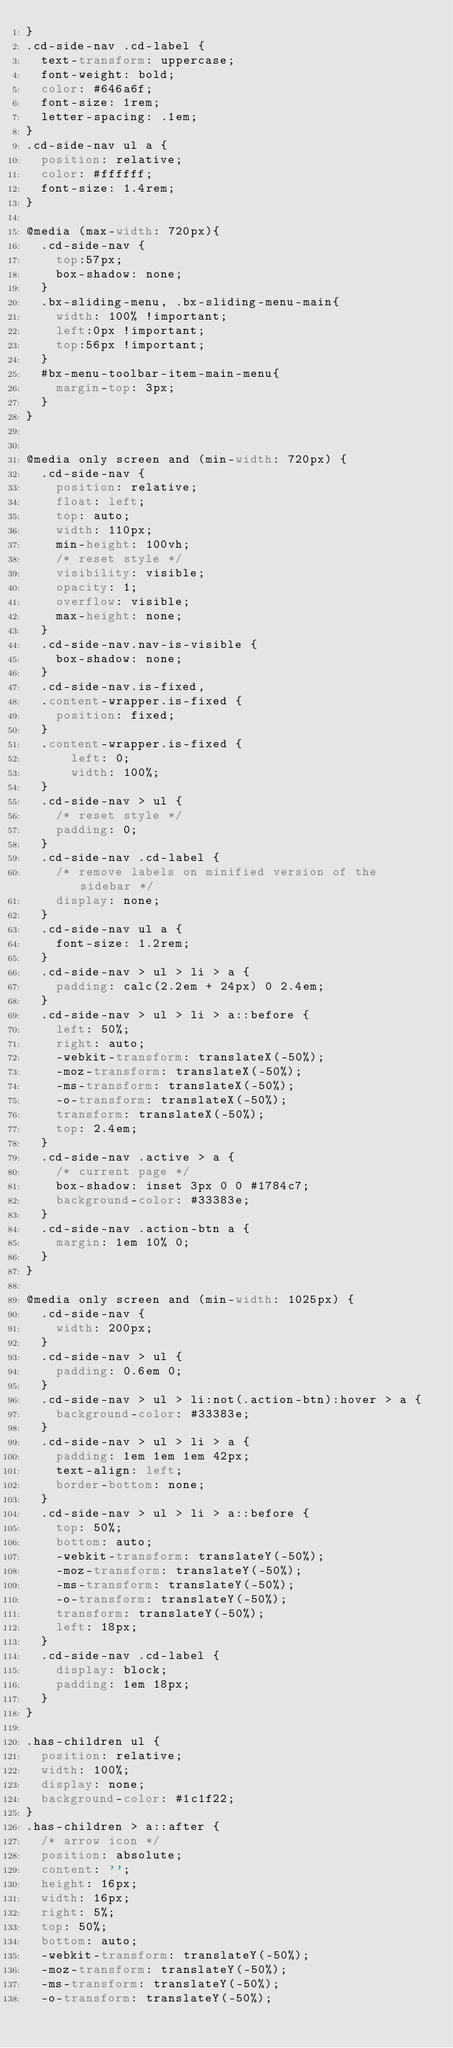Convert code to text. <code><loc_0><loc_0><loc_500><loc_500><_CSS_>}
.cd-side-nav .cd-label {
  text-transform: uppercase;
  font-weight: bold;
  color: #646a6f;
  font-size: 1rem;
  letter-spacing: .1em;
}
.cd-side-nav ul a {
  position: relative;
  color: #ffffff;
  font-size: 1.4rem;
}

@media (max-width: 720px){
	.cd-side-nav {
		top:57px;
		box-shadow: none;
	}
	.bx-sliding-menu, .bx-sliding-menu-main{
		width: 100% !important;
		left:0px !important;
		top:56px !important;
	}
	#bx-menu-toolbar-item-main-menu{
		margin-top: 3px;
	}
}

	
@media only screen and (min-width: 720px) {
  .cd-side-nav {
    position: relative;
    float: left;
    top: auto;
    width: 110px;
    min-height: 100vh;
    /* reset style */
    visibility: visible;
    opacity: 1;
    overflow: visible;
    max-height: none;
  }
  .cd-side-nav.nav-is-visible {
    box-shadow: none;
  }
  .cd-side-nav.is-fixed,
  .content-wrapper.is-fixed {
    position: fixed;
  }
  .content-wrapper.is-fixed {
      left: 0;
      width: 100%;
  }
  .cd-side-nav > ul {
    /* reset style */
    padding: 0;
  }
  .cd-side-nav .cd-label {
    /* remove labels on minified version of the sidebar */
    display: none;
  }
  .cd-side-nav ul a {
    font-size: 1.2rem;
  }
  .cd-side-nav > ul > li > a {
    padding: calc(2.2em + 24px) 0 2.4em;
  }
  .cd-side-nav > ul > li > a::before {
    left: 50%;
    right: auto;
    -webkit-transform: translateX(-50%);
    -moz-transform: translateX(-50%);
    -ms-transform: translateX(-50%);
    -o-transform: translateX(-50%);
    transform: translateX(-50%);
    top: 2.4em;
  }
  .cd-side-nav .active > a {
    /* current page */
    box-shadow: inset 3px 0 0 #1784c7;
    background-color: #33383e;
  }
  .cd-side-nav .action-btn a {
    margin: 1em 10% 0;
  }
}

@media only screen and (min-width: 1025px) {
  .cd-side-nav {
    width: 200px;
  }
  .cd-side-nav > ul {
    padding: 0.6em 0;
  }
  .cd-side-nav > ul > li:not(.action-btn):hover > a {
    background-color: #33383e;
  }
  .cd-side-nav > ul > li > a {
    padding: 1em 1em 1em 42px;
    text-align: left;
    border-bottom: none;
  }
  .cd-side-nav > ul > li > a::before {
    top: 50%;
    bottom: auto;
    -webkit-transform: translateY(-50%);
    -moz-transform: translateY(-50%);
    -ms-transform: translateY(-50%);
    -o-transform: translateY(-50%);
    transform: translateY(-50%);
    left: 18px;
  }
  .cd-side-nav .cd-label {
    display: block;
    padding: 1em 18px;
  }
}

.has-children ul {
  position: relative;
  width: 100%;
  display: none;
  background-color: #1c1f22;
}
.has-children > a::after {
  /* arrow icon */
  position: absolute;
  content: '';
  height: 16px;
  width: 16px;
  right: 5%;
  top: 50%;
  bottom: auto;
  -webkit-transform: translateY(-50%);
  -moz-transform: translateY(-50%);
  -ms-transform: translateY(-50%);
  -o-transform: translateY(-50%);</code> 